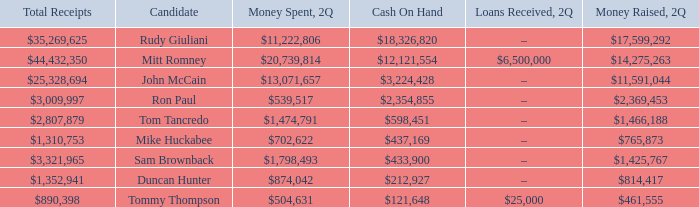Name the money spent for 2Q having candidate of john mccain $13,071,657. 